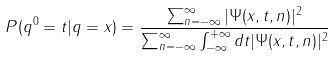<formula> <loc_0><loc_0><loc_500><loc_500>P ( q ^ { 0 } = t | q = x ) = \frac { \sum _ { n = - \infty } ^ { \infty } | \Psi ( x , t , n ) | ^ { 2 } } { \sum _ { n = - \infty } ^ { \infty } \int _ { - \infty } ^ { + \infty } d t | \Psi ( x , t , n ) | ^ { 2 } }</formula> 